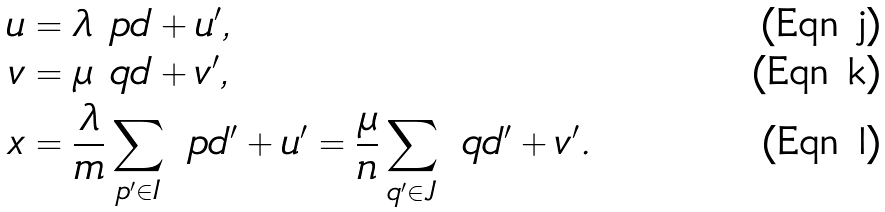Convert formula to latex. <formula><loc_0><loc_0><loc_500><loc_500>u & = \lambda \ p d + u ^ { \prime } , \\ v & = \mu \ q d + v ^ { \prime } , \\ x & = \frac { \lambda } { m } \sum _ { p ^ { \prime } \in I } \ p d ^ { \prime } + u ^ { \prime } = \frac { \mu } { n } \sum _ { q ^ { \prime } \in J } \ q d ^ { \prime } + v ^ { \prime } .</formula> 